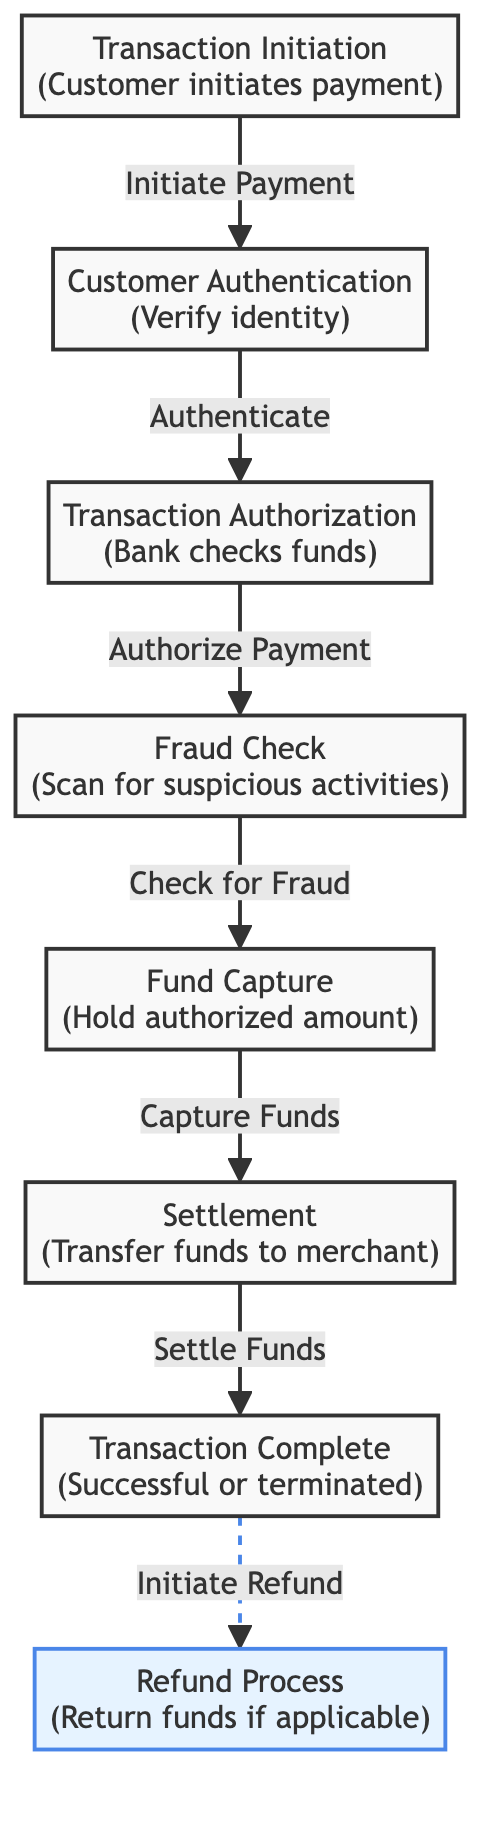What is the first step in the transaction lifecycle? The diagram indicates that the first step in the transaction lifecycle is "Transaction Initiation" where the customer initiates payment.
Answer: Transaction Initiation How many main stages are there in the transaction lifecycle? By counting the major nodes from initiation to settlement, there are a total of six main stages in the transaction lifecycle.
Answer: Six What process follows "Fraud Check"? According to the flow of the diagram, the process that follows "Fraud Check" is "Fund Capture".
Answer: Fund Capture What is the relationship between "Transaction Authorization" and "Fraud Check"? The diagram shows that "Transaction Authorization" leads into "Fraud Check" as the next step, indicating a sequential relationship.
Answer: Sequential relationship How does the transaction complete if it's successful? The diagram indicates that after the "Settlement" step, the flow continues to "Transaction Complete", signaling that this is how the transaction concludes successfully.
Answer: Transaction Complete What action is taken if a refund is initiated? The diagram outlines that if a refund is initiated, it leads to the "Refund Process" where funds are returned if applicable.
Answer: Refund Process Which process involves checking for suspicious activities? The diagram clearly indicates that "Fraud Check" is the process that involves scanning for suspicious activities during the transaction lifecycle.
Answer: Fraud Check What is the final outcome of the transaction referred to in the diagram? The diagram specifies the final outcome of the transaction as "Transaction Complete", which can either be successful or terminated.
Answer: Transaction Complete What type of refund process is indicated in the diagram? The diagram presents the refund process as optional, indicated by the dashed arrow leading from "Transaction Complete" to "Refund Process".
Answer: Optional 